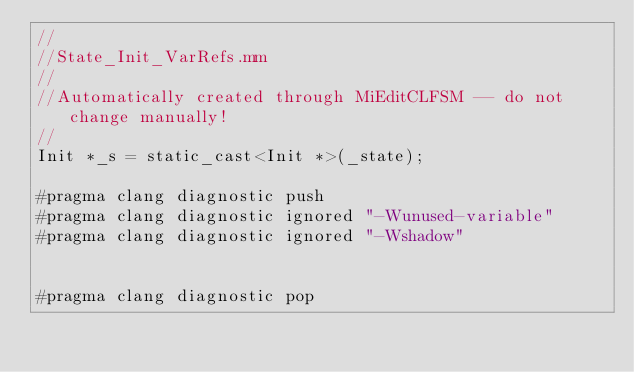<code> <loc_0><loc_0><loc_500><loc_500><_ObjectiveC_>//
//State_Init_VarRefs.mm
//
//Automatically created through MiEditCLFSM -- do not change manually!
//
Init *_s = static_cast<Init *>(_state);

#pragma clang diagnostic push
#pragma clang diagnostic ignored "-Wunused-variable"
#pragma clang diagnostic ignored "-Wshadow"


#pragma clang diagnostic pop
</code> 